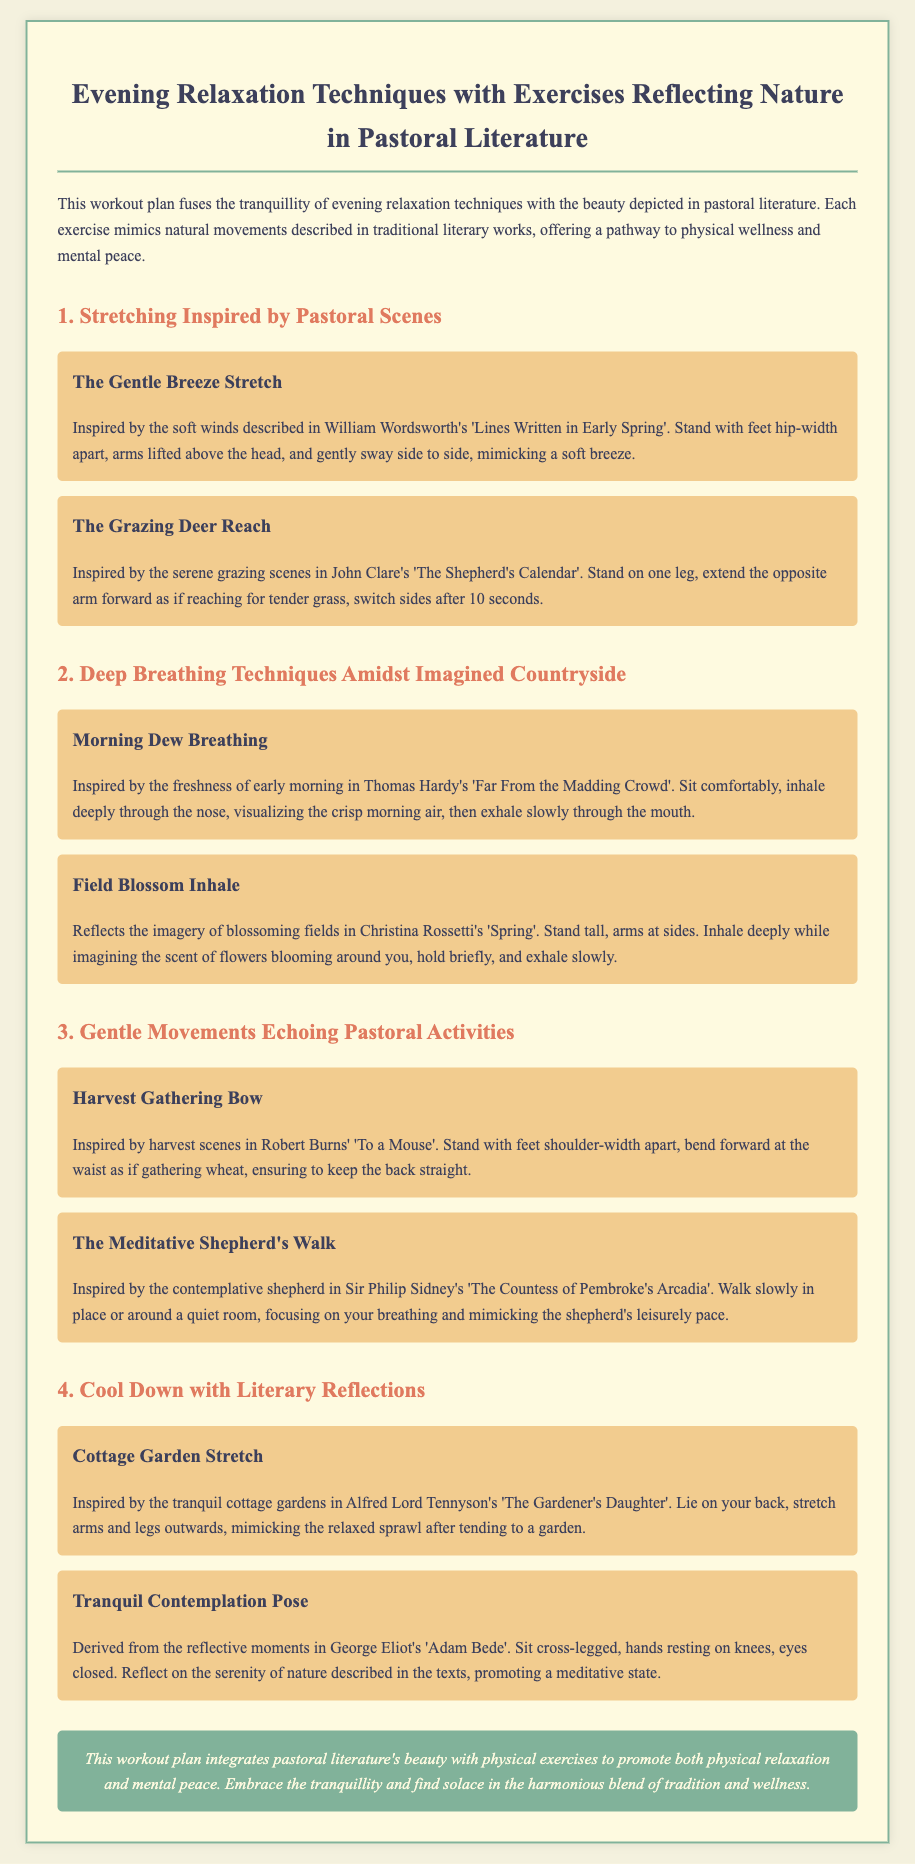What is the title of the workout plan? The title is stated prominently at the beginning of the document and reflects the content related to relaxation techniques and pastoral literature.
Answer: Evening Relaxation Techniques with Exercises Reflecting Nature in Pastoral Literature How many exercises are included in the document? The document contains a total of eight individual exercises categorized under different sections.
Answer: Eight What inspired "The Gentle Breeze Stretch"? The description of this exercise references a specific literary work that evokes natural imagery, specifically from a well-known poet.
Answer: William Wordsworth's 'Lines Written in Early Spring' Which breathing technique is inspired by Thomas Hardy? The document categorizes breathing exercises and links one to Hardy's work that emphasizes freshness and the countryside.
Answer: Morning Dew Breathing What activity does "The Meditative Shepherd's Walk" reflect? This exercise draws inspiration from a pastoral scene that involves leisurely movement and contemplation, highlighting the slow pace of a specific character.
Answer: The contemplative shepherd What is the purpose of the final stretch exercise? The document provides context for this exercise and links it to reflective literary themes, enhancing the relaxation experience after physical activity.
Answer: To promote a meditative state Which poet’s work inspired the "Harvest Gathering Bow"? This exercise is based on the imagery of harvest in a classical poem known for its reflection on nature and agriculture.
Answer: Robert Burns' 'To a Mouse' What time of day is this workout plan designed for? The title and introductory paragraph indicate the specific time associated with the relaxation techniques.
Answer: Evening 